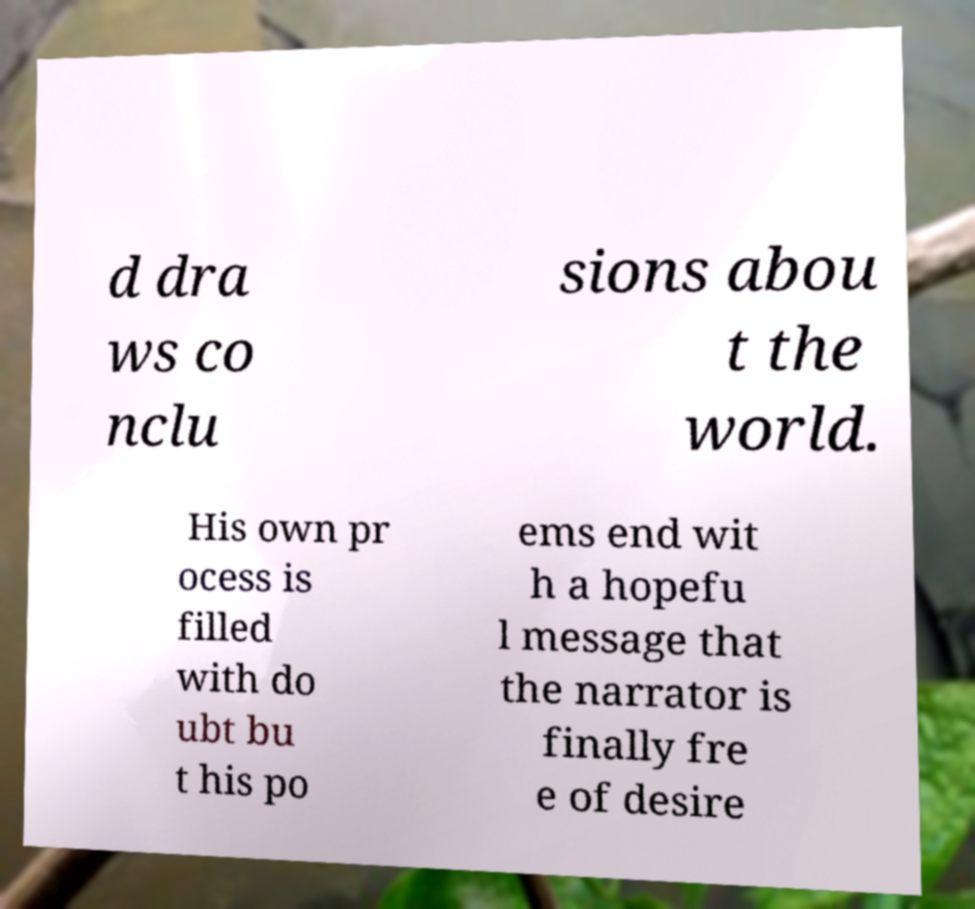Could you extract and type out the text from this image? d dra ws co nclu sions abou t the world. His own pr ocess is filled with do ubt bu t his po ems end wit h a hopefu l message that the narrator is finally fre e of desire 